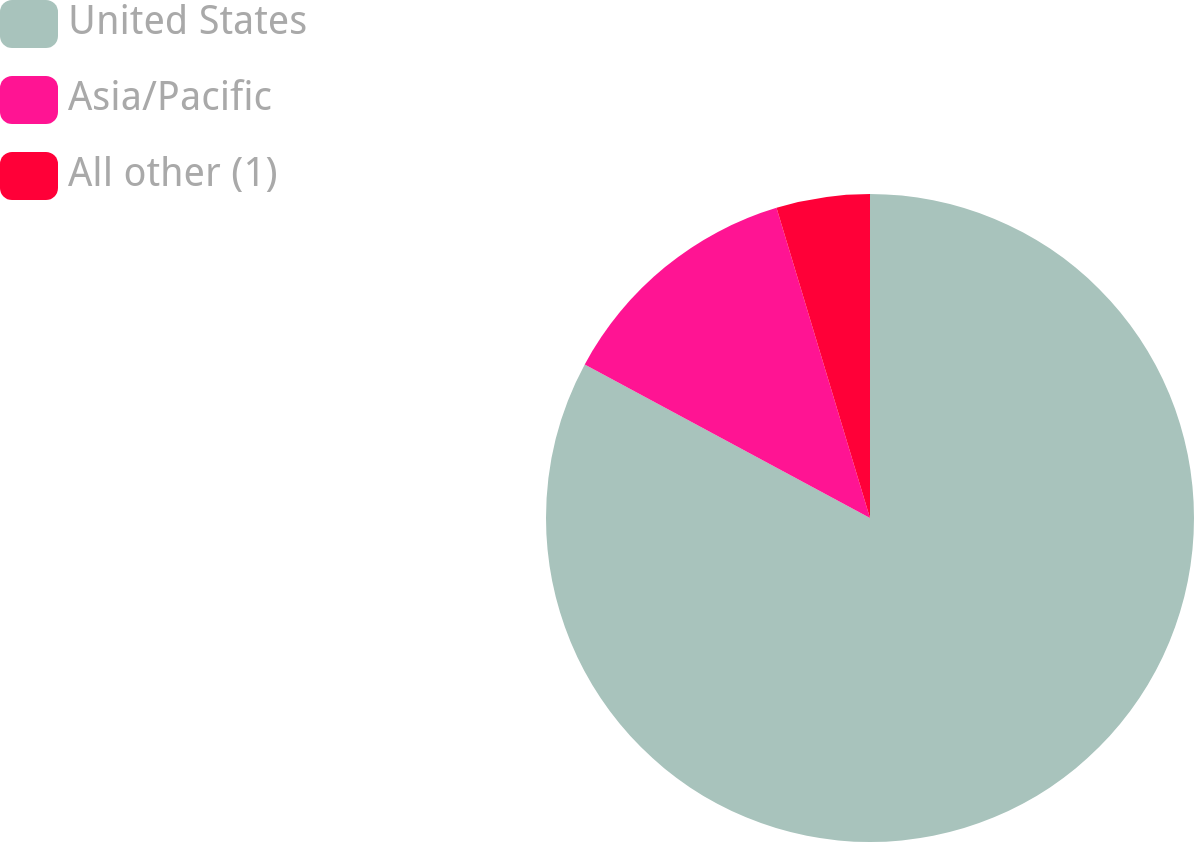<chart> <loc_0><loc_0><loc_500><loc_500><pie_chart><fcel>United States<fcel>Asia/Pacific<fcel>All other (1)<nl><fcel>82.87%<fcel>12.48%<fcel>4.66%<nl></chart> 